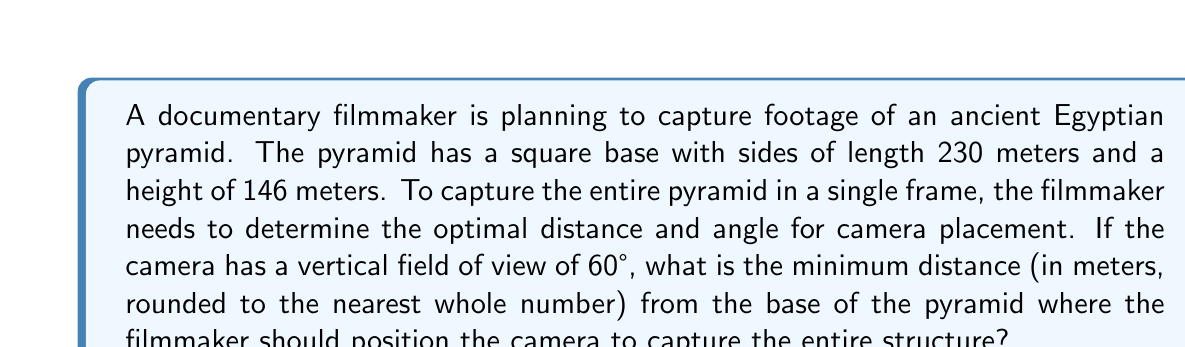What is the answer to this math problem? Let's approach this step-by-step:

1) First, we need to understand the geometry of the situation. The camera's field of view forms a triangle, with the camera at the apex and the pyramid fitting within this triangle.

2) We can split this problem into two right triangles: one formed by the camera, the base of the pyramid, and the ground; and another formed by the camera, the top of the pyramid, and the vertical line from the camera to the ground.

3) Let's define some variables:
   $d$ = distance from the camera to the base of the pyramid
   $h$ = height of the pyramid (146 m)
   $\theta$ = half of the vertical field of view (60°/2 = 30°)

4) In the larger right triangle, we have:
   $\tan(\theta) = \frac{h}{d}$

5) Solving for $d$:
   $d = \frac{h}{\tan(\theta)} = \frac{146}{\tan(30°)}$

6) Calculate:
   $d = \frac{146}{\tan(30°)} \approx 252.89$ meters

7) Round to the nearest whole number:
   $d \approx 253$ meters

[asy]
import geometry;

unitsize(0.5cm);

pair A = (0,0), B = (10,0), C = (5,8), D = (0,8), E = (-10,0);

draw(A--B--C--A);
draw(D--E);
draw(C--D);

label("Pyramid", (5,3));
label("Camera", (-10,0), W);
label("Ground", (0,-0.5));
label("$d$", (-5,0), N);
label("$h$", (0,4), W);
label("$\theta$", (-9.5,0.5), NE);

dot("", A);
dot("", B);
dot("", C);
dot("", D);
dot("", E);
[/asy]
Answer: 253 meters 